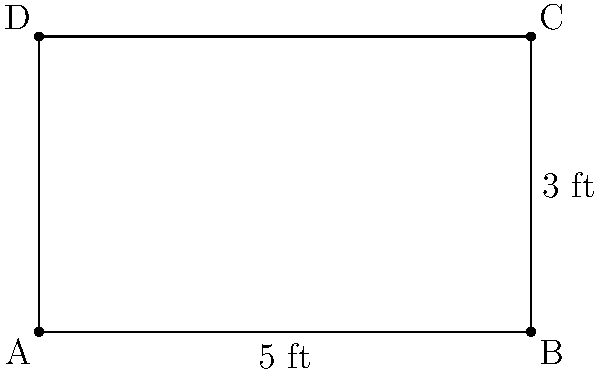A children's library is designing a new rectangular bookshelf for picture books. The shelf has a length of 5 feet and a height of 3 feet, as shown in the diagram. What is the perimeter of this bookshelf in feet? To calculate the perimeter of the rectangular bookshelf, we need to sum up the lengths of all sides. Let's break it down step-by-step:

1. Identify the dimensions:
   Length (L) = 5 feet
   Height (H) = 3 feet

2. Recall the formula for the perimeter of a rectangle:
   Perimeter = 2L + 2H

3. Substitute the values into the formula:
   Perimeter = 2(5 ft) + 2(3 ft)

4. Multiply:
   Perimeter = 10 ft + 6 ft

5. Sum up the results:
   Perimeter = 16 ft

Therefore, the perimeter of the rectangular bookshelf is 16 feet.
Answer: 16 ft 